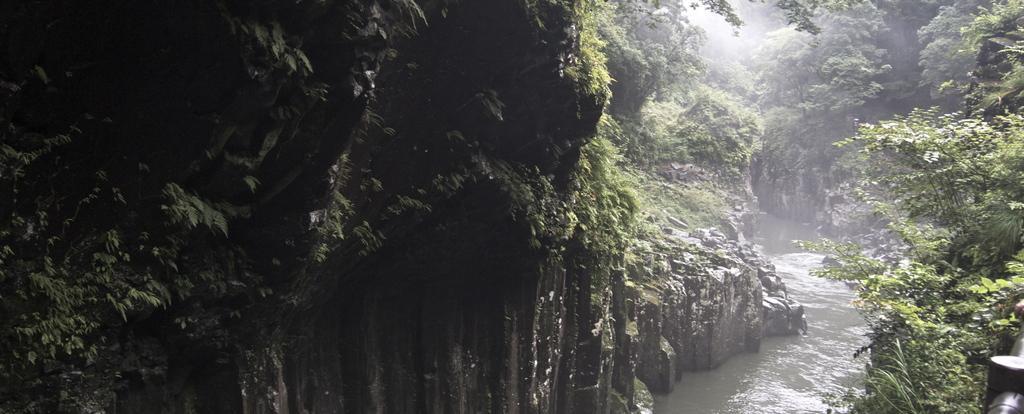In one or two sentences, can you explain what this image depicts? In this image we can see trees, rocks, creeper plants and a lake. 